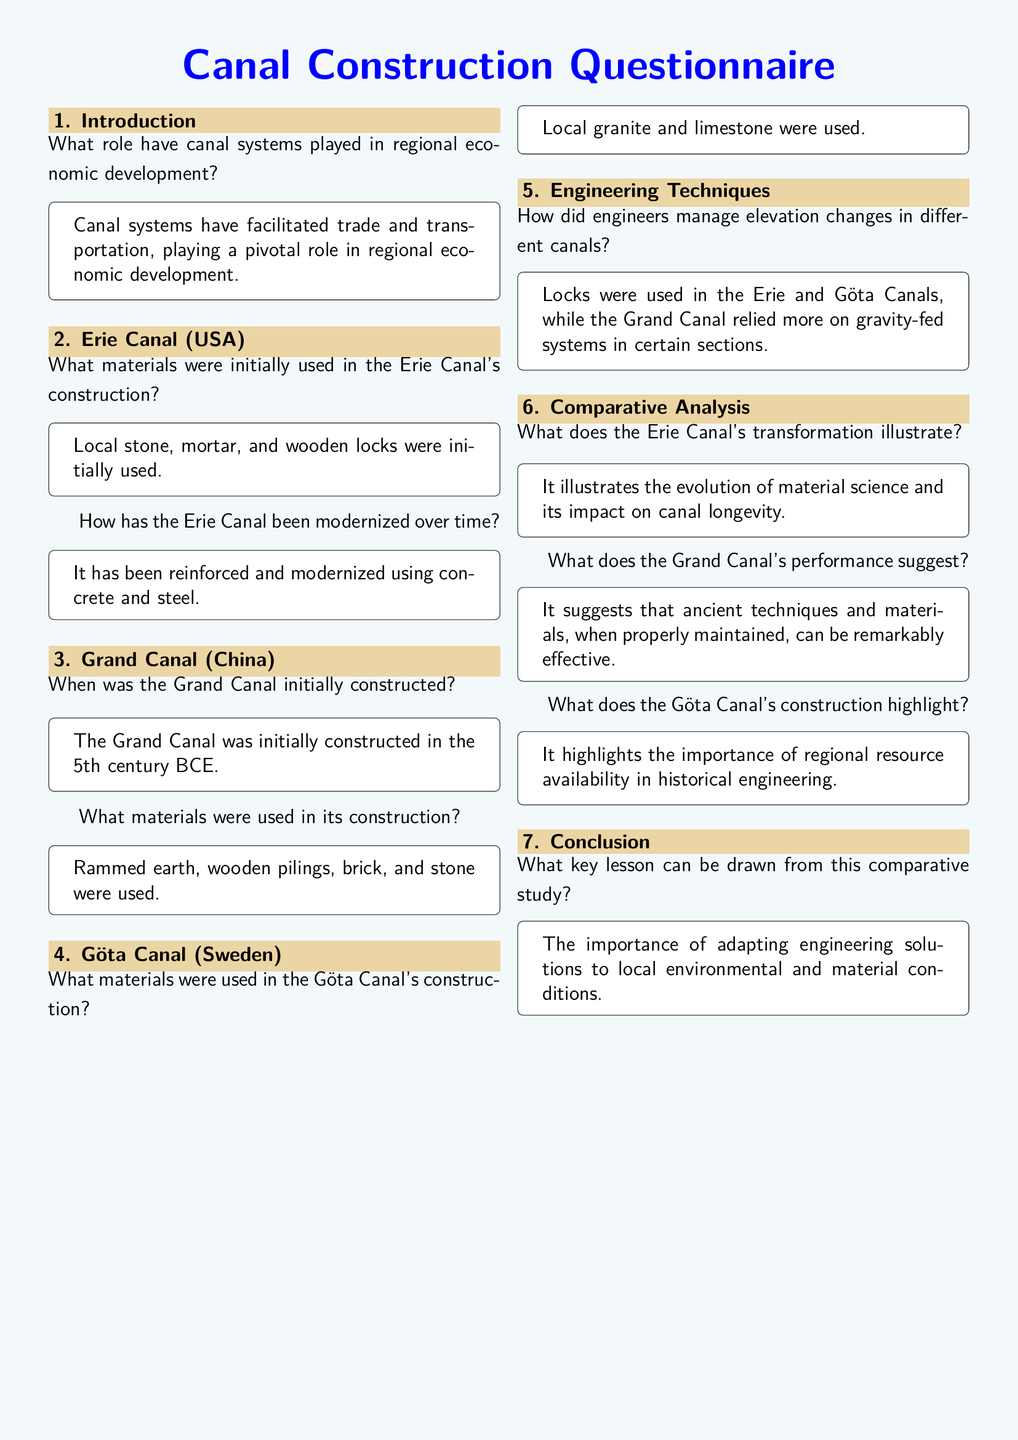What role have canal systems played in regional economic development? The document states that canal systems have facilitated trade and transportation, playing a pivotal role in regional economic development.
Answer: Regional economic development What materials were used in the Erie Canal's construction? According to the document, local stone, mortar, and wooden locks were initially used for construction.
Answer: Local stone, mortar, and wooden locks When was the Grand Canal initially constructed? The document mentions that the Grand Canal was initially constructed in the 5th century BCE.
Answer: 5th century BCE What materials were used to construct the Göta Canal? The document specifies that local granite and limestone were used in the construction of the Göta Canal.
Answer: Local granite and limestone What engineering method was used for elevation changes in the Erie Canal? The document indicates that locks were used to manage elevation changes in the Erie Canal.
Answer: Locks What does the Erie Canal's transformation illustrate? It is stated in the document that it illustrates the evolution of material science and its impact on canal longevity.
Answer: Evolution of material science What key lesson can be drawn from the comparative study? The document concludes that the key lesson is the importance of adapting engineering solutions to local environmental and material conditions.
Answer: Adapting engineering solutions What technique did the Grand Canal rely on in certain sections? The document states that the Grand Canal relied more on gravity-fed systems in certain sections.
Answer: Gravity-fed systems What does the Göta Canal's construction highlight? According to the document, it highlights the importance of regional resource availability in historical engineering.
Answer: Regional resource availability 